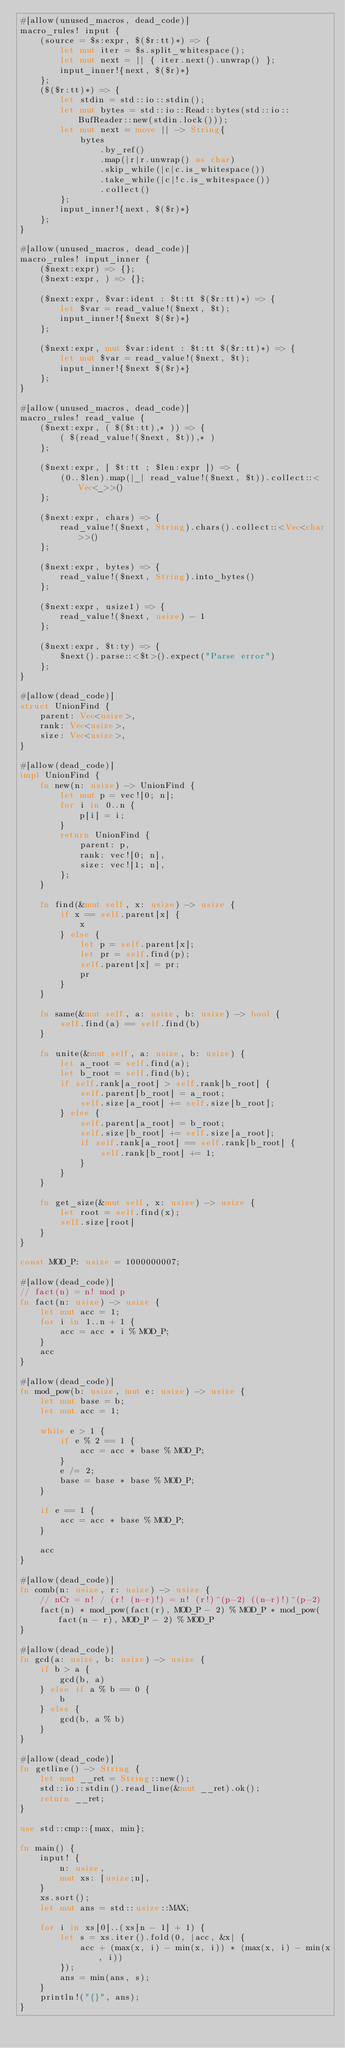<code> <loc_0><loc_0><loc_500><loc_500><_Rust_>#[allow(unused_macros, dead_code)]
macro_rules! input {
    (source = $s:expr, $($r:tt)*) => {
        let mut iter = $s.split_whitespace();
        let mut next = || { iter.next().unwrap() };
        input_inner!{next, $($r)*}
    };
    ($($r:tt)*) => {
        let stdin = std::io::stdin();
        let mut bytes = std::io::Read::bytes(std::io::BufReader::new(stdin.lock()));
        let mut next = move || -> String{
            bytes
                .by_ref()
                .map(|r|r.unwrap() as char)
                .skip_while(|c|c.is_whitespace())
                .take_while(|c|!c.is_whitespace())
                .collect()
        };
        input_inner!{next, $($r)*}
    };
}

#[allow(unused_macros, dead_code)]
macro_rules! input_inner {
    ($next:expr) => {};
    ($next:expr, ) => {};

    ($next:expr, $var:ident : $t:tt $($r:tt)*) => {
        let $var = read_value!($next, $t);
        input_inner!{$next $($r)*}
    };

    ($next:expr, mut $var:ident : $t:tt $($r:tt)*) => {
        let mut $var = read_value!($next, $t);
        input_inner!{$next $($r)*}
    };
}

#[allow(unused_macros, dead_code)]
macro_rules! read_value {
    ($next:expr, ( $($t:tt),* )) => {
        ( $(read_value!($next, $t)),* )
    };

    ($next:expr, [ $t:tt ; $len:expr ]) => {
        (0..$len).map(|_| read_value!($next, $t)).collect::<Vec<_>>()
    };

    ($next:expr, chars) => {
        read_value!($next, String).chars().collect::<Vec<char>>()
    };

    ($next:expr, bytes) => {
        read_value!($next, String).into_bytes()
    };

    ($next:expr, usize1) => {
        read_value!($next, usize) - 1
    };

    ($next:expr, $t:ty) => {
        $next().parse::<$t>().expect("Parse error")
    };
}

#[allow(dead_code)]
struct UnionFind {
    parent: Vec<usize>,
    rank: Vec<usize>,
    size: Vec<usize>,
}

#[allow(dead_code)]
impl UnionFind {
    fn new(n: usize) -> UnionFind {
        let mut p = vec![0; n];
        for i in 0..n {
            p[i] = i;
        }
        return UnionFind {
            parent: p,
            rank: vec![0; n],
            size: vec![1; n],
        };
    }

    fn find(&mut self, x: usize) -> usize {
        if x == self.parent[x] {
            x
        } else {
            let p = self.parent[x];
            let pr = self.find(p);
            self.parent[x] = pr;
            pr
        }
    }

    fn same(&mut self, a: usize, b: usize) -> bool {
        self.find(a) == self.find(b)
    }

    fn unite(&mut self, a: usize, b: usize) {
        let a_root = self.find(a);
        let b_root = self.find(b);
        if self.rank[a_root] > self.rank[b_root] {
            self.parent[b_root] = a_root;
            self.size[a_root] += self.size[b_root];
        } else {
            self.parent[a_root] = b_root;
            self.size[b_root] += self.size[a_root];
            if self.rank[a_root] == self.rank[b_root] {
                self.rank[b_root] += 1;
            }
        }
    }

    fn get_size(&mut self, x: usize) -> usize {
        let root = self.find(x);
        self.size[root]
    }
}

const MOD_P: usize = 1000000007;

#[allow(dead_code)]
// fact(n) = n! mod p
fn fact(n: usize) -> usize {
    let mut acc = 1;
    for i in 1..n + 1 {
        acc = acc * i % MOD_P;
    }
    acc
}

#[allow(dead_code)]
fn mod_pow(b: usize, mut e: usize) -> usize {
    let mut base = b;
    let mut acc = 1;

    while e > 1 {
        if e % 2 == 1 {
            acc = acc * base % MOD_P;
        }
        e /= 2;
        base = base * base % MOD_P;
    }

    if e == 1 {
        acc = acc * base % MOD_P;
    }

    acc
}

#[allow(dead_code)]
fn comb(n: usize, r: usize) -> usize {
    // nCr = n! / (r! (n-r)!) = n! (r!)^(p-2) ((n-r)!)^(p-2)
    fact(n) * mod_pow(fact(r), MOD_P - 2) % MOD_P * mod_pow(fact(n - r), MOD_P - 2) % MOD_P
}

#[allow(dead_code)]
fn gcd(a: usize, b: usize) -> usize {
    if b > a {
        gcd(b, a)
    } else if a % b == 0 {
        b
    } else {
        gcd(b, a % b)
    }
}

#[allow(dead_code)]
fn getline() -> String {
    let mut __ret = String::new();
    std::io::stdin().read_line(&mut __ret).ok();
    return __ret;
}

use std::cmp::{max, min};

fn main() {
    input! {
        n: usize,
        mut xs: [usize;n],
    }
    xs.sort();
    let mut ans = std::usize::MAX;

    for i in xs[0]..(xs[n - 1] + 1) {
        let s = xs.iter().fold(0, |acc, &x| {
            acc + (max(x, i) - min(x, i)) * (max(x, i) - min(x, i))
        });
        ans = min(ans, s);
    }
    println!("{}", ans);
}
</code> 